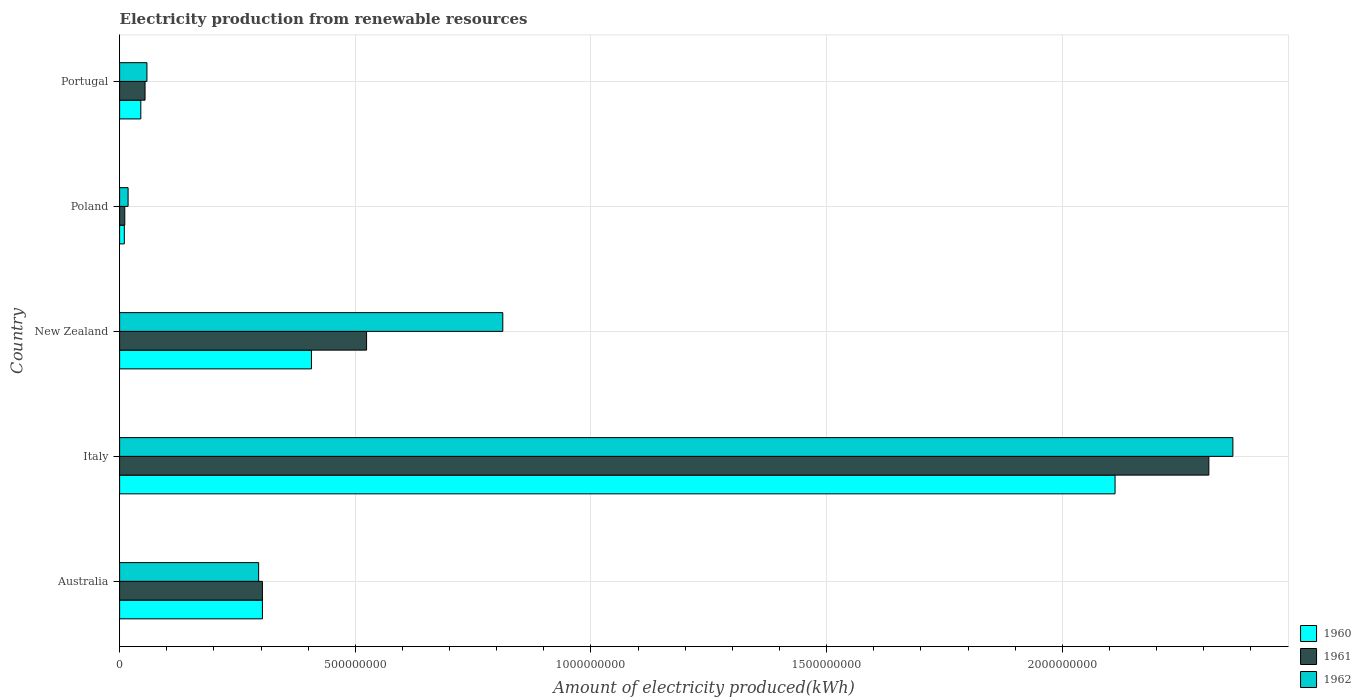How many different coloured bars are there?
Keep it short and to the point. 3. Are the number of bars per tick equal to the number of legend labels?
Ensure brevity in your answer.  Yes. Are the number of bars on each tick of the Y-axis equal?
Make the answer very short. Yes. How many bars are there on the 3rd tick from the top?
Your answer should be very brief. 3. In how many cases, is the number of bars for a given country not equal to the number of legend labels?
Offer a very short reply. 0. What is the amount of electricity produced in 1960 in New Zealand?
Your answer should be compact. 4.07e+08. Across all countries, what is the maximum amount of electricity produced in 1961?
Make the answer very short. 2.31e+09. Across all countries, what is the minimum amount of electricity produced in 1961?
Keep it short and to the point. 1.10e+07. In which country was the amount of electricity produced in 1961 maximum?
Ensure brevity in your answer.  Italy. What is the total amount of electricity produced in 1961 in the graph?
Your answer should be very brief. 3.20e+09. What is the difference between the amount of electricity produced in 1962 in Italy and that in Portugal?
Make the answer very short. 2.30e+09. What is the difference between the amount of electricity produced in 1962 in New Zealand and the amount of electricity produced in 1960 in Italy?
Your answer should be very brief. -1.30e+09. What is the average amount of electricity produced in 1962 per country?
Your response must be concise. 7.09e+08. What is the difference between the amount of electricity produced in 1960 and amount of electricity produced in 1962 in Portugal?
Your answer should be compact. -1.30e+07. In how many countries, is the amount of electricity produced in 1962 greater than 1300000000 kWh?
Make the answer very short. 1. What is the ratio of the amount of electricity produced in 1962 in Poland to that in Portugal?
Your response must be concise. 0.31. What is the difference between the highest and the second highest amount of electricity produced in 1961?
Your answer should be compact. 1.79e+09. What is the difference between the highest and the lowest amount of electricity produced in 1962?
Your answer should be very brief. 2.34e+09. What does the 3rd bar from the top in Poland represents?
Your response must be concise. 1960. Are all the bars in the graph horizontal?
Ensure brevity in your answer.  Yes. What is the difference between two consecutive major ticks on the X-axis?
Ensure brevity in your answer.  5.00e+08. Are the values on the major ticks of X-axis written in scientific E-notation?
Your response must be concise. No. Where does the legend appear in the graph?
Provide a succinct answer. Bottom right. How many legend labels are there?
Ensure brevity in your answer.  3. What is the title of the graph?
Offer a terse response. Electricity production from renewable resources. Does "1970" appear as one of the legend labels in the graph?
Offer a terse response. No. What is the label or title of the X-axis?
Offer a very short reply. Amount of electricity produced(kWh). What is the Amount of electricity produced(kWh) of 1960 in Australia?
Ensure brevity in your answer.  3.03e+08. What is the Amount of electricity produced(kWh) in 1961 in Australia?
Keep it short and to the point. 3.03e+08. What is the Amount of electricity produced(kWh) of 1962 in Australia?
Your answer should be very brief. 2.95e+08. What is the Amount of electricity produced(kWh) in 1960 in Italy?
Provide a succinct answer. 2.11e+09. What is the Amount of electricity produced(kWh) in 1961 in Italy?
Provide a short and direct response. 2.31e+09. What is the Amount of electricity produced(kWh) of 1962 in Italy?
Provide a succinct answer. 2.36e+09. What is the Amount of electricity produced(kWh) in 1960 in New Zealand?
Your response must be concise. 4.07e+08. What is the Amount of electricity produced(kWh) in 1961 in New Zealand?
Provide a short and direct response. 5.24e+08. What is the Amount of electricity produced(kWh) of 1962 in New Zealand?
Offer a terse response. 8.13e+08. What is the Amount of electricity produced(kWh) of 1960 in Poland?
Offer a terse response. 1.00e+07. What is the Amount of electricity produced(kWh) in 1961 in Poland?
Ensure brevity in your answer.  1.10e+07. What is the Amount of electricity produced(kWh) in 1962 in Poland?
Your answer should be very brief. 1.80e+07. What is the Amount of electricity produced(kWh) of 1960 in Portugal?
Your answer should be compact. 4.50e+07. What is the Amount of electricity produced(kWh) of 1961 in Portugal?
Your response must be concise. 5.40e+07. What is the Amount of electricity produced(kWh) of 1962 in Portugal?
Keep it short and to the point. 5.80e+07. Across all countries, what is the maximum Amount of electricity produced(kWh) of 1960?
Keep it short and to the point. 2.11e+09. Across all countries, what is the maximum Amount of electricity produced(kWh) of 1961?
Provide a succinct answer. 2.31e+09. Across all countries, what is the maximum Amount of electricity produced(kWh) in 1962?
Provide a short and direct response. 2.36e+09. Across all countries, what is the minimum Amount of electricity produced(kWh) of 1960?
Provide a short and direct response. 1.00e+07. Across all countries, what is the minimum Amount of electricity produced(kWh) of 1961?
Your answer should be compact. 1.10e+07. Across all countries, what is the minimum Amount of electricity produced(kWh) of 1962?
Give a very brief answer. 1.80e+07. What is the total Amount of electricity produced(kWh) of 1960 in the graph?
Offer a terse response. 2.88e+09. What is the total Amount of electricity produced(kWh) of 1961 in the graph?
Your answer should be compact. 3.20e+09. What is the total Amount of electricity produced(kWh) of 1962 in the graph?
Your answer should be very brief. 3.55e+09. What is the difference between the Amount of electricity produced(kWh) of 1960 in Australia and that in Italy?
Offer a very short reply. -1.81e+09. What is the difference between the Amount of electricity produced(kWh) of 1961 in Australia and that in Italy?
Make the answer very short. -2.01e+09. What is the difference between the Amount of electricity produced(kWh) in 1962 in Australia and that in Italy?
Your response must be concise. -2.07e+09. What is the difference between the Amount of electricity produced(kWh) of 1960 in Australia and that in New Zealand?
Give a very brief answer. -1.04e+08. What is the difference between the Amount of electricity produced(kWh) in 1961 in Australia and that in New Zealand?
Your answer should be very brief. -2.21e+08. What is the difference between the Amount of electricity produced(kWh) of 1962 in Australia and that in New Zealand?
Offer a terse response. -5.18e+08. What is the difference between the Amount of electricity produced(kWh) of 1960 in Australia and that in Poland?
Make the answer very short. 2.93e+08. What is the difference between the Amount of electricity produced(kWh) of 1961 in Australia and that in Poland?
Your answer should be very brief. 2.92e+08. What is the difference between the Amount of electricity produced(kWh) in 1962 in Australia and that in Poland?
Your answer should be compact. 2.77e+08. What is the difference between the Amount of electricity produced(kWh) in 1960 in Australia and that in Portugal?
Offer a terse response. 2.58e+08. What is the difference between the Amount of electricity produced(kWh) of 1961 in Australia and that in Portugal?
Ensure brevity in your answer.  2.49e+08. What is the difference between the Amount of electricity produced(kWh) in 1962 in Australia and that in Portugal?
Provide a short and direct response. 2.37e+08. What is the difference between the Amount of electricity produced(kWh) of 1960 in Italy and that in New Zealand?
Offer a very short reply. 1.70e+09. What is the difference between the Amount of electricity produced(kWh) of 1961 in Italy and that in New Zealand?
Keep it short and to the point. 1.79e+09. What is the difference between the Amount of electricity produced(kWh) in 1962 in Italy and that in New Zealand?
Your answer should be very brief. 1.55e+09. What is the difference between the Amount of electricity produced(kWh) of 1960 in Italy and that in Poland?
Keep it short and to the point. 2.10e+09. What is the difference between the Amount of electricity produced(kWh) in 1961 in Italy and that in Poland?
Your response must be concise. 2.30e+09. What is the difference between the Amount of electricity produced(kWh) of 1962 in Italy and that in Poland?
Ensure brevity in your answer.  2.34e+09. What is the difference between the Amount of electricity produced(kWh) of 1960 in Italy and that in Portugal?
Ensure brevity in your answer.  2.07e+09. What is the difference between the Amount of electricity produced(kWh) in 1961 in Italy and that in Portugal?
Your response must be concise. 2.26e+09. What is the difference between the Amount of electricity produced(kWh) of 1962 in Italy and that in Portugal?
Provide a short and direct response. 2.30e+09. What is the difference between the Amount of electricity produced(kWh) of 1960 in New Zealand and that in Poland?
Your answer should be compact. 3.97e+08. What is the difference between the Amount of electricity produced(kWh) of 1961 in New Zealand and that in Poland?
Your answer should be compact. 5.13e+08. What is the difference between the Amount of electricity produced(kWh) of 1962 in New Zealand and that in Poland?
Give a very brief answer. 7.95e+08. What is the difference between the Amount of electricity produced(kWh) in 1960 in New Zealand and that in Portugal?
Ensure brevity in your answer.  3.62e+08. What is the difference between the Amount of electricity produced(kWh) of 1961 in New Zealand and that in Portugal?
Provide a short and direct response. 4.70e+08. What is the difference between the Amount of electricity produced(kWh) in 1962 in New Zealand and that in Portugal?
Provide a succinct answer. 7.55e+08. What is the difference between the Amount of electricity produced(kWh) of 1960 in Poland and that in Portugal?
Provide a succinct answer. -3.50e+07. What is the difference between the Amount of electricity produced(kWh) of 1961 in Poland and that in Portugal?
Give a very brief answer. -4.30e+07. What is the difference between the Amount of electricity produced(kWh) in 1962 in Poland and that in Portugal?
Your answer should be very brief. -4.00e+07. What is the difference between the Amount of electricity produced(kWh) of 1960 in Australia and the Amount of electricity produced(kWh) of 1961 in Italy?
Make the answer very short. -2.01e+09. What is the difference between the Amount of electricity produced(kWh) in 1960 in Australia and the Amount of electricity produced(kWh) in 1962 in Italy?
Your response must be concise. -2.06e+09. What is the difference between the Amount of electricity produced(kWh) in 1961 in Australia and the Amount of electricity produced(kWh) in 1962 in Italy?
Provide a succinct answer. -2.06e+09. What is the difference between the Amount of electricity produced(kWh) of 1960 in Australia and the Amount of electricity produced(kWh) of 1961 in New Zealand?
Your answer should be very brief. -2.21e+08. What is the difference between the Amount of electricity produced(kWh) of 1960 in Australia and the Amount of electricity produced(kWh) of 1962 in New Zealand?
Your answer should be very brief. -5.10e+08. What is the difference between the Amount of electricity produced(kWh) of 1961 in Australia and the Amount of electricity produced(kWh) of 1962 in New Zealand?
Your answer should be compact. -5.10e+08. What is the difference between the Amount of electricity produced(kWh) of 1960 in Australia and the Amount of electricity produced(kWh) of 1961 in Poland?
Give a very brief answer. 2.92e+08. What is the difference between the Amount of electricity produced(kWh) in 1960 in Australia and the Amount of electricity produced(kWh) in 1962 in Poland?
Make the answer very short. 2.85e+08. What is the difference between the Amount of electricity produced(kWh) in 1961 in Australia and the Amount of electricity produced(kWh) in 1962 in Poland?
Ensure brevity in your answer.  2.85e+08. What is the difference between the Amount of electricity produced(kWh) in 1960 in Australia and the Amount of electricity produced(kWh) in 1961 in Portugal?
Provide a short and direct response. 2.49e+08. What is the difference between the Amount of electricity produced(kWh) in 1960 in Australia and the Amount of electricity produced(kWh) in 1962 in Portugal?
Offer a very short reply. 2.45e+08. What is the difference between the Amount of electricity produced(kWh) in 1961 in Australia and the Amount of electricity produced(kWh) in 1962 in Portugal?
Your response must be concise. 2.45e+08. What is the difference between the Amount of electricity produced(kWh) of 1960 in Italy and the Amount of electricity produced(kWh) of 1961 in New Zealand?
Offer a terse response. 1.59e+09. What is the difference between the Amount of electricity produced(kWh) of 1960 in Italy and the Amount of electricity produced(kWh) of 1962 in New Zealand?
Keep it short and to the point. 1.30e+09. What is the difference between the Amount of electricity produced(kWh) of 1961 in Italy and the Amount of electricity produced(kWh) of 1962 in New Zealand?
Provide a succinct answer. 1.50e+09. What is the difference between the Amount of electricity produced(kWh) in 1960 in Italy and the Amount of electricity produced(kWh) in 1961 in Poland?
Provide a short and direct response. 2.10e+09. What is the difference between the Amount of electricity produced(kWh) of 1960 in Italy and the Amount of electricity produced(kWh) of 1962 in Poland?
Give a very brief answer. 2.09e+09. What is the difference between the Amount of electricity produced(kWh) in 1961 in Italy and the Amount of electricity produced(kWh) in 1962 in Poland?
Keep it short and to the point. 2.29e+09. What is the difference between the Amount of electricity produced(kWh) of 1960 in Italy and the Amount of electricity produced(kWh) of 1961 in Portugal?
Offer a very short reply. 2.06e+09. What is the difference between the Amount of electricity produced(kWh) of 1960 in Italy and the Amount of electricity produced(kWh) of 1962 in Portugal?
Provide a short and direct response. 2.05e+09. What is the difference between the Amount of electricity produced(kWh) of 1961 in Italy and the Amount of electricity produced(kWh) of 1962 in Portugal?
Provide a succinct answer. 2.25e+09. What is the difference between the Amount of electricity produced(kWh) of 1960 in New Zealand and the Amount of electricity produced(kWh) of 1961 in Poland?
Provide a short and direct response. 3.96e+08. What is the difference between the Amount of electricity produced(kWh) in 1960 in New Zealand and the Amount of electricity produced(kWh) in 1962 in Poland?
Your response must be concise. 3.89e+08. What is the difference between the Amount of electricity produced(kWh) in 1961 in New Zealand and the Amount of electricity produced(kWh) in 1962 in Poland?
Provide a succinct answer. 5.06e+08. What is the difference between the Amount of electricity produced(kWh) of 1960 in New Zealand and the Amount of electricity produced(kWh) of 1961 in Portugal?
Provide a succinct answer. 3.53e+08. What is the difference between the Amount of electricity produced(kWh) of 1960 in New Zealand and the Amount of electricity produced(kWh) of 1962 in Portugal?
Provide a short and direct response. 3.49e+08. What is the difference between the Amount of electricity produced(kWh) in 1961 in New Zealand and the Amount of electricity produced(kWh) in 1962 in Portugal?
Offer a terse response. 4.66e+08. What is the difference between the Amount of electricity produced(kWh) in 1960 in Poland and the Amount of electricity produced(kWh) in 1961 in Portugal?
Offer a very short reply. -4.40e+07. What is the difference between the Amount of electricity produced(kWh) of 1960 in Poland and the Amount of electricity produced(kWh) of 1962 in Portugal?
Provide a short and direct response. -4.80e+07. What is the difference between the Amount of electricity produced(kWh) of 1961 in Poland and the Amount of electricity produced(kWh) of 1962 in Portugal?
Provide a short and direct response. -4.70e+07. What is the average Amount of electricity produced(kWh) in 1960 per country?
Keep it short and to the point. 5.75e+08. What is the average Amount of electricity produced(kWh) in 1961 per country?
Make the answer very short. 6.41e+08. What is the average Amount of electricity produced(kWh) of 1962 per country?
Provide a short and direct response. 7.09e+08. What is the difference between the Amount of electricity produced(kWh) in 1960 and Amount of electricity produced(kWh) in 1961 in Italy?
Your answer should be very brief. -1.99e+08. What is the difference between the Amount of electricity produced(kWh) in 1960 and Amount of electricity produced(kWh) in 1962 in Italy?
Make the answer very short. -2.50e+08. What is the difference between the Amount of electricity produced(kWh) of 1961 and Amount of electricity produced(kWh) of 1962 in Italy?
Make the answer very short. -5.10e+07. What is the difference between the Amount of electricity produced(kWh) of 1960 and Amount of electricity produced(kWh) of 1961 in New Zealand?
Give a very brief answer. -1.17e+08. What is the difference between the Amount of electricity produced(kWh) in 1960 and Amount of electricity produced(kWh) in 1962 in New Zealand?
Make the answer very short. -4.06e+08. What is the difference between the Amount of electricity produced(kWh) in 1961 and Amount of electricity produced(kWh) in 1962 in New Zealand?
Offer a terse response. -2.89e+08. What is the difference between the Amount of electricity produced(kWh) in 1960 and Amount of electricity produced(kWh) in 1962 in Poland?
Ensure brevity in your answer.  -8.00e+06. What is the difference between the Amount of electricity produced(kWh) in 1961 and Amount of electricity produced(kWh) in 1962 in Poland?
Offer a very short reply. -7.00e+06. What is the difference between the Amount of electricity produced(kWh) in 1960 and Amount of electricity produced(kWh) in 1961 in Portugal?
Your answer should be compact. -9.00e+06. What is the difference between the Amount of electricity produced(kWh) in 1960 and Amount of electricity produced(kWh) in 1962 in Portugal?
Offer a very short reply. -1.30e+07. What is the difference between the Amount of electricity produced(kWh) of 1961 and Amount of electricity produced(kWh) of 1962 in Portugal?
Ensure brevity in your answer.  -4.00e+06. What is the ratio of the Amount of electricity produced(kWh) of 1960 in Australia to that in Italy?
Keep it short and to the point. 0.14. What is the ratio of the Amount of electricity produced(kWh) of 1961 in Australia to that in Italy?
Your response must be concise. 0.13. What is the ratio of the Amount of electricity produced(kWh) of 1962 in Australia to that in Italy?
Offer a very short reply. 0.12. What is the ratio of the Amount of electricity produced(kWh) in 1960 in Australia to that in New Zealand?
Your response must be concise. 0.74. What is the ratio of the Amount of electricity produced(kWh) in 1961 in Australia to that in New Zealand?
Make the answer very short. 0.58. What is the ratio of the Amount of electricity produced(kWh) of 1962 in Australia to that in New Zealand?
Make the answer very short. 0.36. What is the ratio of the Amount of electricity produced(kWh) of 1960 in Australia to that in Poland?
Your answer should be very brief. 30.3. What is the ratio of the Amount of electricity produced(kWh) in 1961 in Australia to that in Poland?
Offer a terse response. 27.55. What is the ratio of the Amount of electricity produced(kWh) of 1962 in Australia to that in Poland?
Your answer should be very brief. 16.39. What is the ratio of the Amount of electricity produced(kWh) of 1960 in Australia to that in Portugal?
Your response must be concise. 6.73. What is the ratio of the Amount of electricity produced(kWh) in 1961 in Australia to that in Portugal?
Give a very brief answer. 5.61. What is the ratio of the Amount of electricity produced(kWh) in 1962 in Australia to that in Portugal?
Provide a succinct answer. 5.09. What is the ratio of the Amount of electricity produced(kWh) of 1960 in Italy to that in New Zealand?
Keep it short and to the point. 5.19. What is the ratio of the Amount of electricity produced(kWh) in 1961 in Italy to that in New Zealand?
Offer a very short reply. 4.41. What is the ratio of the Amount of electricity produced(kWh) of 1962 in Italy to that in New Zealand?
Your answer should be very brief. 2.91. What is the ratio of the Amount of electricity produced(kWh) in 1960 in Italy to that in Poland?
Your answer should be very brief. 211.2. What is the ratio of the Amount of electricity produced(kWh) in 1961 in Italy to that in Poland?
Your answer should be very brief. 210.09. What is the ratio of the Amount of electricity produced(kWh) in 1962 in Italy to that in Poland?
Provide a succinct answer. 131.22. What is the ratio of the Amount of electricity produced(kWh) of 1960 in Italy to that in Portugal?
Your answer should be compact. 46.93. What is the ratio of the Amount of electricity produced(kWh) of 1961 in Italy to that in Portugal?
Provide a succinct answer. 42.8. What is the ratio of the Amount of electricity produced(kWh) in 1962 in Italy to that in Portugal?
Provide a short and direct response. 40.72. What is the ratio of the Amount of electricity produced(kWh) in 1960 in New Zealand to that in Poland?
Your answer should be very brief. 40.7. What is the ratio of the Amount of electricity produced(kWh) of 1961 in New Zealand to that in Poland?
Provide a succinct answer. 47.64. What is the ratio of the Amount of electricity produced(kWh) of 1962 in New Zealand to that in Poland?
Ensure brevity in your answer.  45.17. What is the ratio of the Amount of electricity produced(kWh) of 1960 in New Zealand to that in Portugal?
Keep it short and to the point. 9.04. What is the ratio of the Amount of electricity produced(kWh) in 1961 in New Zealand to that in Portugal?
Provide a short and direct response. 9.7. What is the ratio of the Amount of electricity produced(kWh) in 1962 in New Zealand to that in Portugal?
Provide a succinct answer. 14.02. What is the ratio of the Amount of electricity produced(kWh) in 1960 in Poland to that in Portugal?
Offer a very short reply. 0.22. What is the ratio of the Amount of electricity produced(kWh) in 1961 in Poland to that in Portugal?
Your answer should be very brief. 0.2. What is the ratio of the Amount of electricity produced(kWh) of 1962 in Poland to that in Portugal?
Your answer should be very brief. 0.31. What is the difference between the highest and the second highest Amount of electricity produced(kWh) in 1960?
Give a very brief answer. 1.70e+09. What is the difference between the highest and the second highest Amount of electricity produced(kWh) of 1961?
Make the answer very short. 1.79e+09. What is the difference between the highest and the second highest Amount of electricity produced(kWh) in 1962?
Provide a succinct answer. 1.55e+09. What is the difference between the highest and the lowest Amount of electricity produced(kWh) in 1960?
Provide a succinct answer. 2.10e+09. What is the difference between the highest and the lowest Amount of electricity produced(kWh) of 1961?
Make the answer very short. 2.30e+09. What is the difference between the highest and the lowest Amount of electricity produced(kWh) of 1962?
Ensure brevity in your answer.  2.34e+09. 